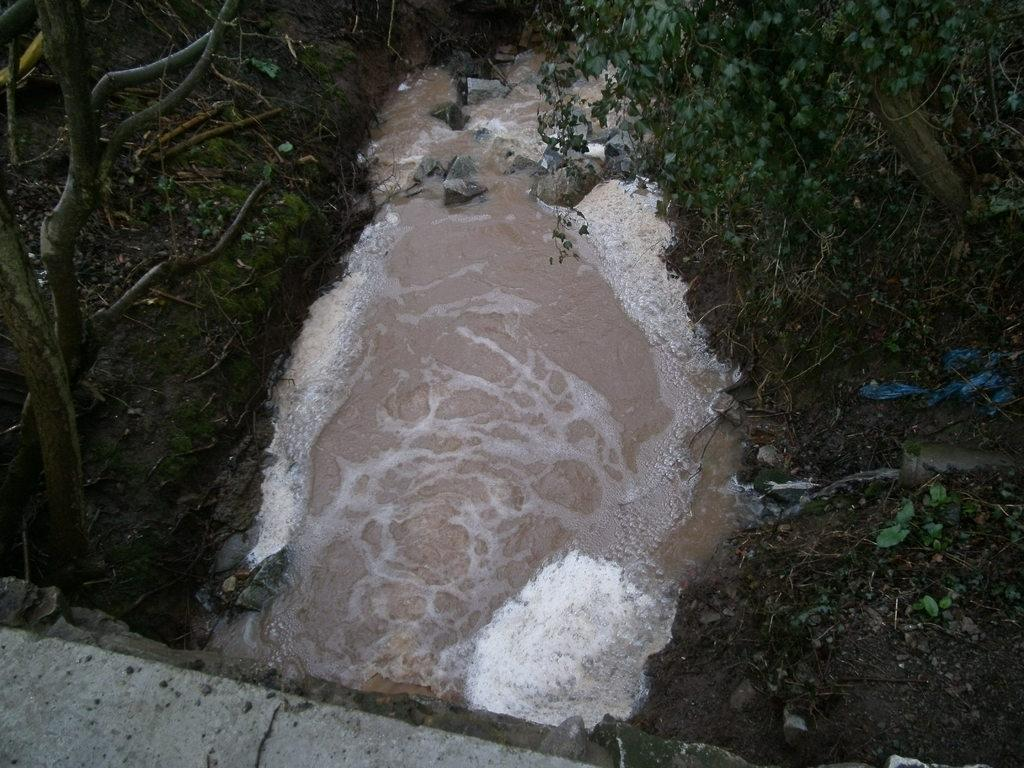What is the main feature of the image? There is a small pond in the image. What is happening in the pond? Water is flowing in the pond. What type of vegetation is present near the pond? There are trees and small plants on both sides of the pond. What structure can be seen at the bottom of the image? There is a bridge wall at the bottom of the image. What type of toothpaste is being used in the image? There is no toothpaste present in the image. What reason is given for the water flowing in the pond in the image? The image does not provide a reason for the water flowing in the pond; it simply shows the water in motion. 